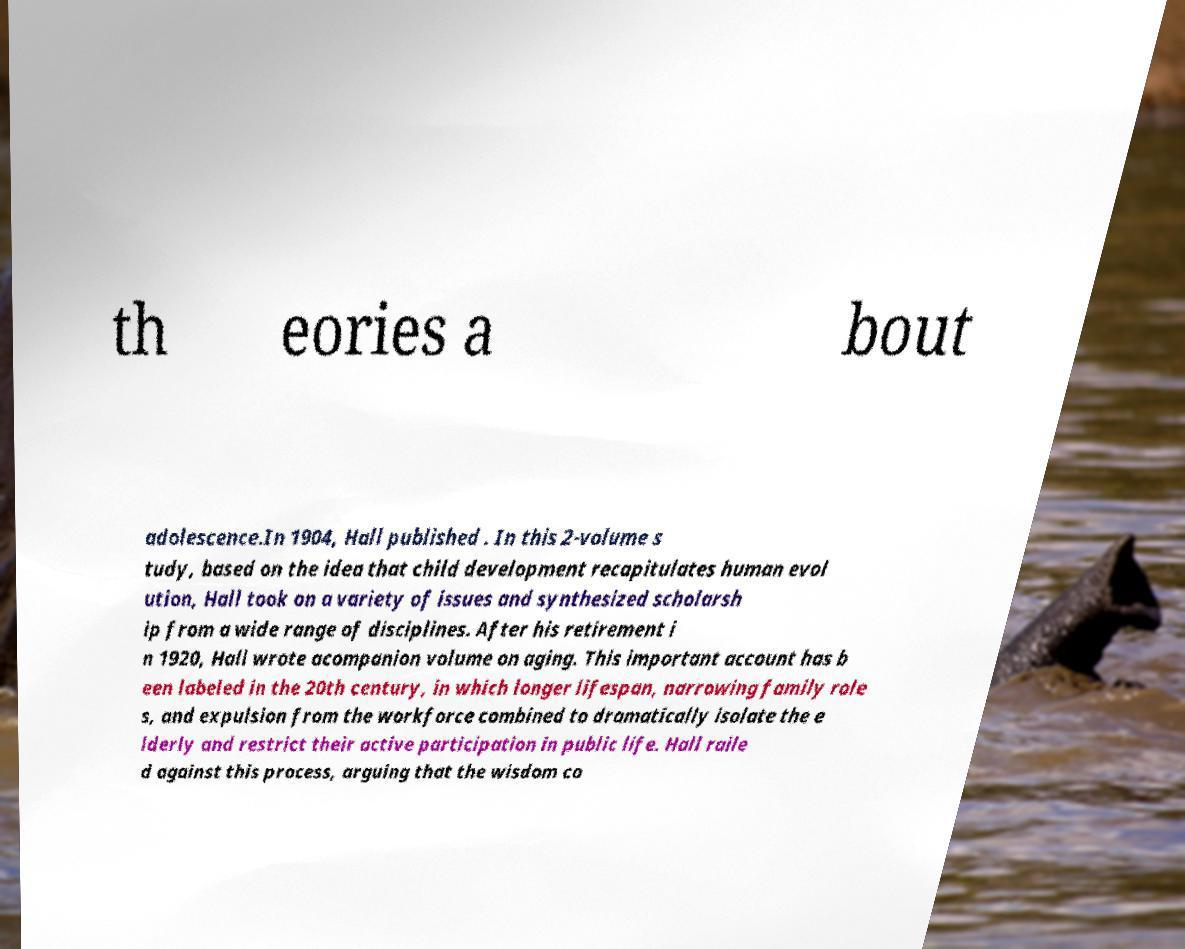Could you extract and type out the text from this image? th eories a bout adolescence.In 1904, Hall published . In this 2-volume s tudy, based on the idea that child development recapitulates human evol ution, Hall took on a variety of issues and synthesized scholarsh ip from a wide range of disciplines. After his retirement i n 1920, Hall wrote acompanion volume on aging. This important account has b een labeled in the 20th century, in which longer lifespan, narrowing family role s, and expulsion from the workforce combined to dramatically isolate the e lderly and restrict their active participation in public life. Hall raile d against this process, arguing that the wisdom co 